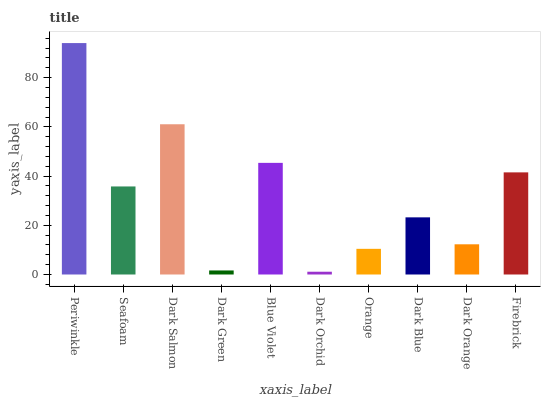Is Dark Orchid the minimum?
Answer yes or no. Yes. Is Periwinkle the maximum?
Answer yes or no. Yes. Is Seafoam the minimum?
Answer yes or no. No. Is Seafoam the maximum?
Answer yes or no. No. Is Periwinkle greater than Seafoam?
Answer yes or no. Yes. Is Seafoam less than Periwinkle?
Answer yes or no. Yes. Is Seafoam greater than Periwinkle?
Answer yes or no. No. Is Periwinkle less than Seafoam?
Answer yes or no. No. Is Seafoam the high median?
Answer yes or no. Yes. Is Dark Blue the low median?
Answer yes or no. Yes. Is Orange the high median?
Answer yes or no. No. Is Periwinkle the low median?
Answer yes or no. No. 